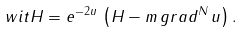<formula> <loc_0><loc_0><loc_500><loc_500>\ w i t { H } = e ^ { - 2 u } \, \left ( H - m \, g r a d ^ { N } \, u \right ) .</formula> 